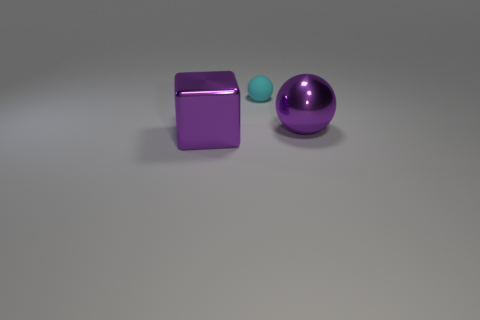Add 3 small brown metallic objects. How many objects exist? 6 Subtract all cubes. How many objects are left? 2 Subtract 0 cyan cylinders. How many objects are left? 3 Subtract all big brown matte cubes. Subtract all purple objects. How many objects are left? 1 Add 2 big metallic things. How many big metallic things are left? 4 Add 3 matte objects. How many matte objects exist? 4 